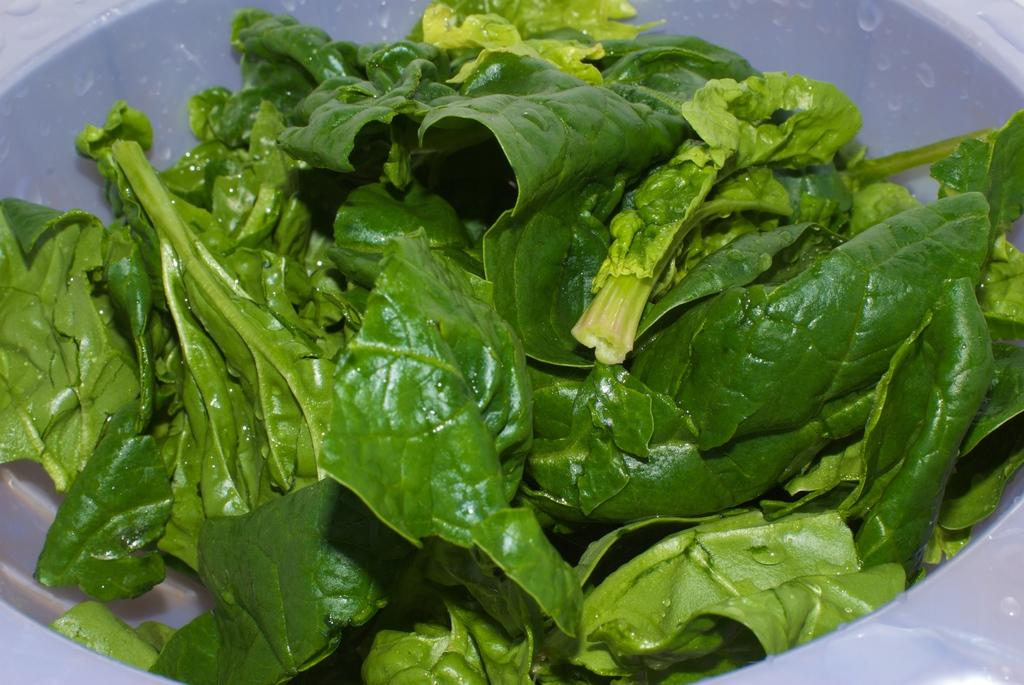What type of vegetation is present in the image? There are green leaves in the image. Where are the green leaves located? The green leaves are in a bowl. What type of lock is used to secure the wine in the middle of the image? There is no lock or wine present in the image; it only features green leaves in a bowl. 